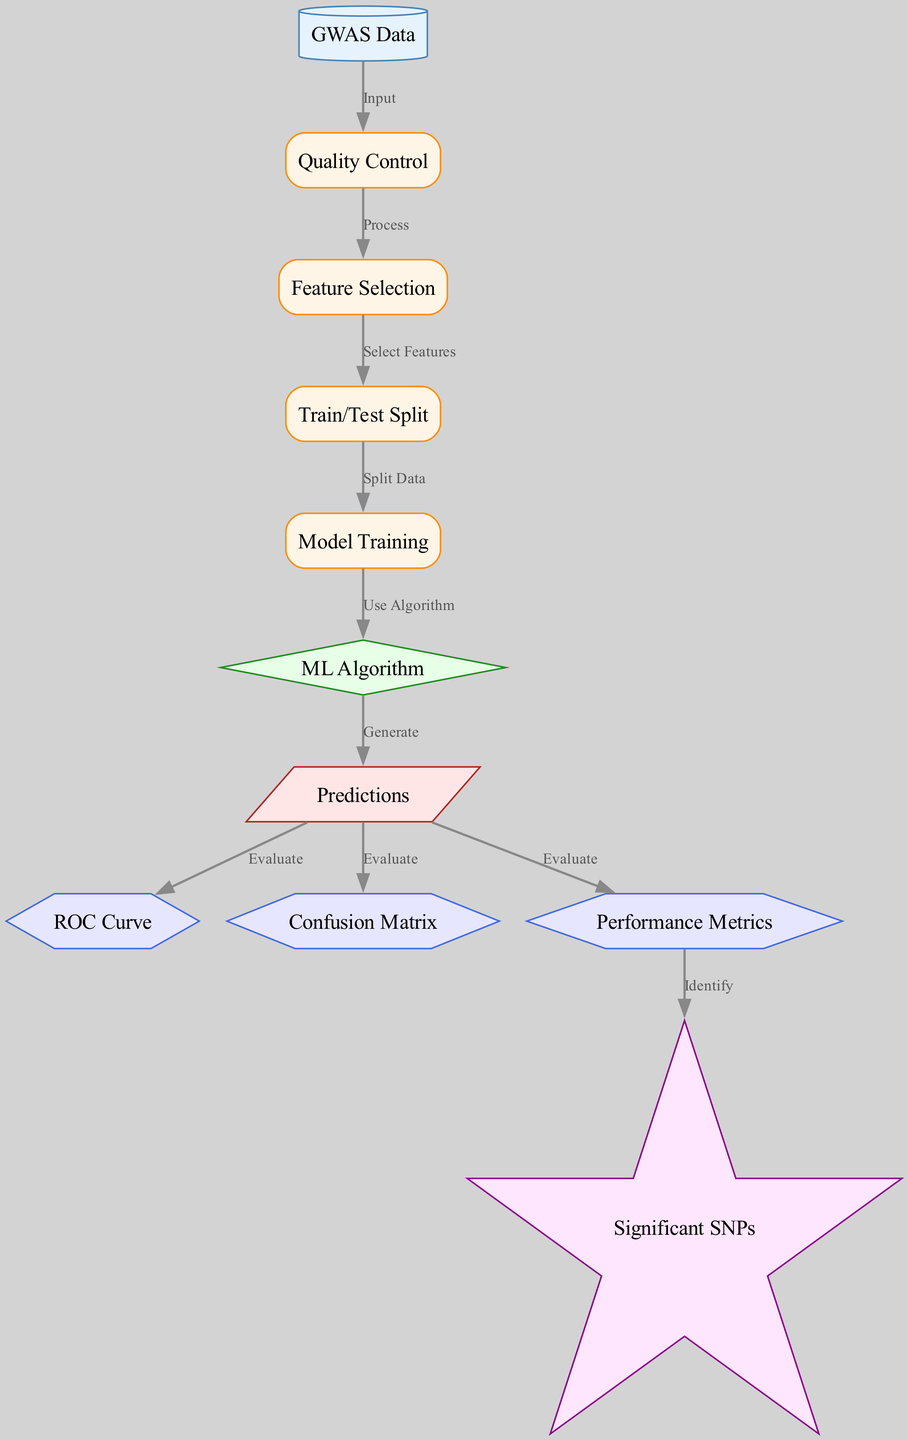What is the first node in the diagram? The first node, representing the starting point of the process, is labeled "GWAS Data." It serves as the input to the entire evaluation process.
Answer: GWAS Data How many evaluation nodes are there in total? There are three evaluation nodes in the diagram, which are "ROC Curve," "Confusion Matrix," and "Performance Metrics." Each of these nodes serves a unique role in evaluating the model's predictions.
Answer: 3 What process follows quality control? After the "Quality Control" process, the next step is "Feature Selection." This indicates that the data must be prepped and relevant features chosen before further analysis.
Answer: Feature Selection Which node generates predictions? The "ML Algorithm" node leads to the "Predictions" node, indicating that predictions are generated after applying the selected machine learning algorithm.
Answer: Predictions Which nodes are evaluated based on the predictions? The nodes evaluated based on predictions are "ROC Curve," "Confusion Matrix," and "Performance Metrics," all of which analyze different aspects of the prediction results.
Answer: ROC Curve, Confusion Matrix, Performance Metrics How are significant SNPs identified? "Performance Metrics" node provides the necessary evaluations that lead to identifying the "Significant SNPs," indicating that understanding performance is crucial for determining significance in this context.
Answer: Performance Metrics What does the edge from "Train/Test Split" to "Model Training" signify? The edge indicates a direct flow from "Train/Test Split" to "Model Training," meaning that after the data is split, the next logical step in the process is to train the ML algorithm on the training set.
Answer: Use Algorithm How many total nodes are there in the diagram? The total number of nodes in the diagram is eleven, incorporating data sources, processes, models, outputs, evaluations, and results. This comprehensive inclusion reflects the entire pipeline used in GWAS.
Answer: 11 